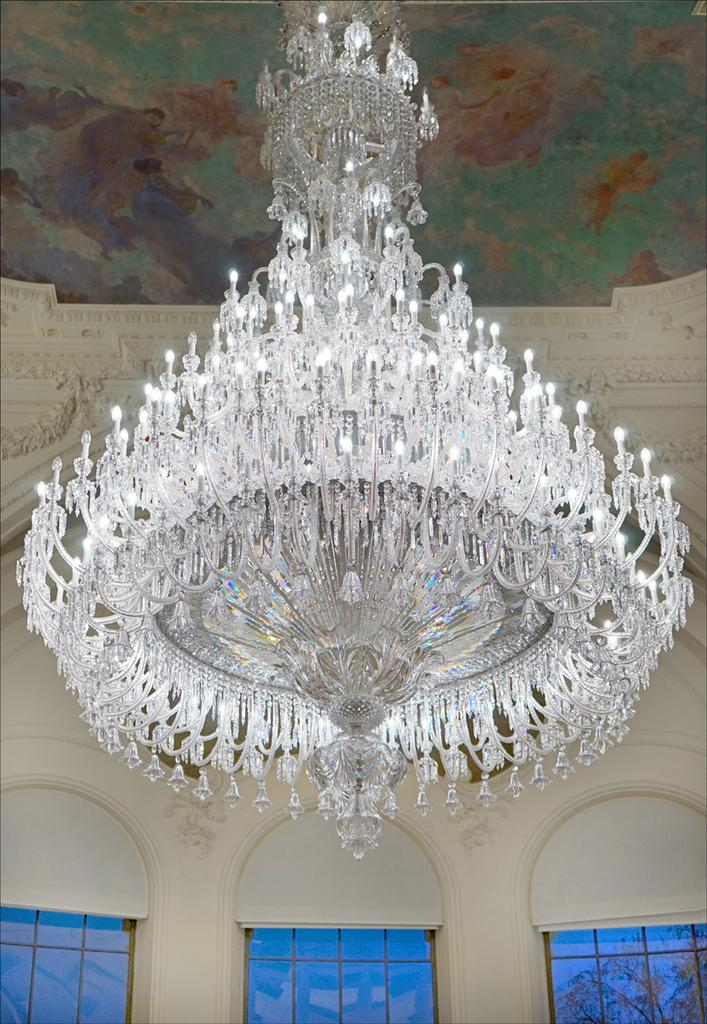What type of location is depicted in the image? The image is an inside view of a building. What can be seen above the room in the image? There is a ceiling visible in the image. Are there any openings to the outside in the image? Yes, there are windows in the image. What type of berry is being used to act as a doorstop in the image? There is no berry or doorstop present in the image; it is an inside view of a building with a ceiling and windows. 